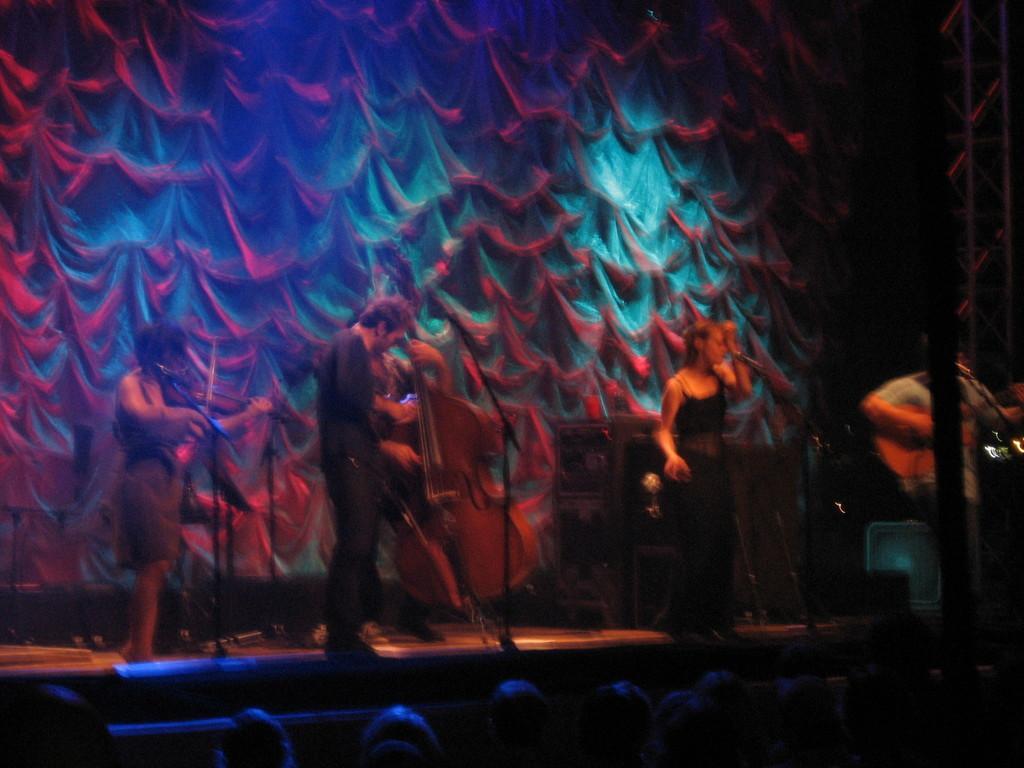In one or two sentences, can you explain what this image depicts? In this image, there are a few people. Among them, we can see some people on the stage. We can see some musical instruments and microphones. In the background, we can see some cloth. We can also see an object on the right. 